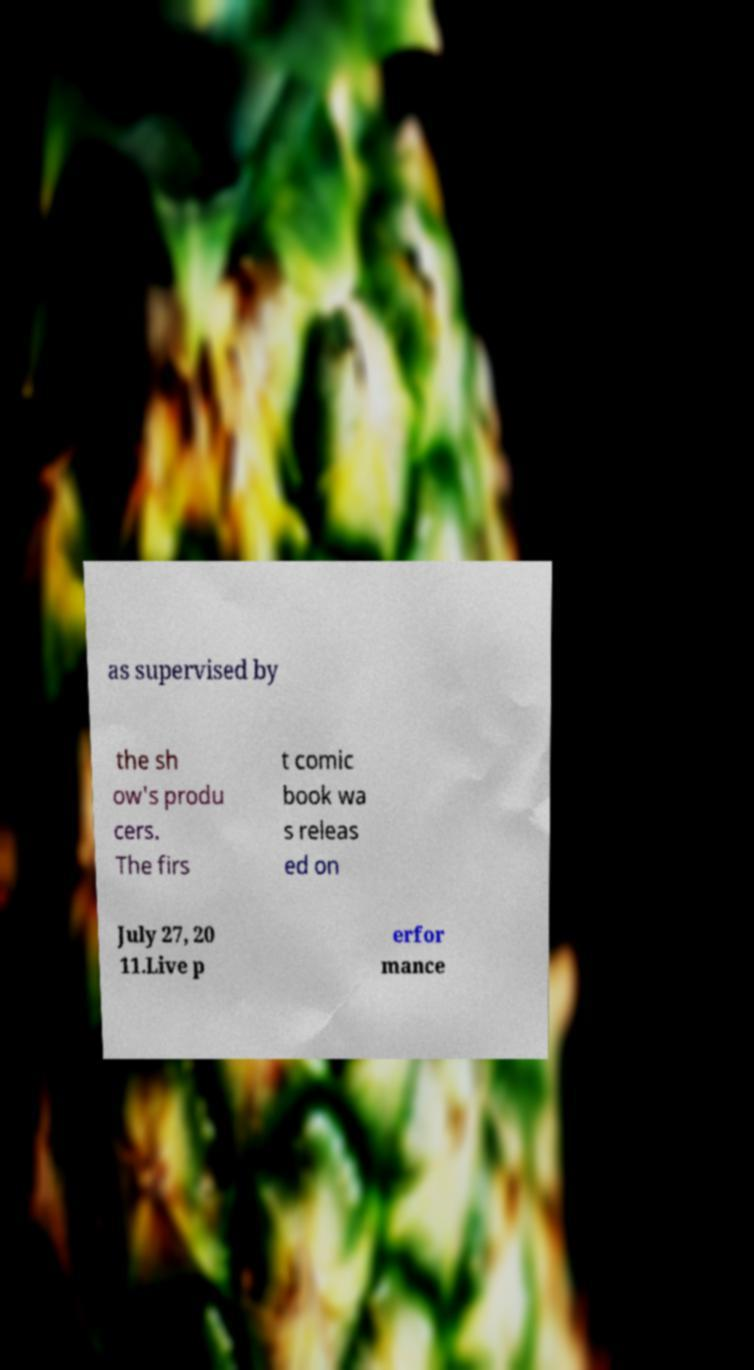Can you read and provide the text displayed in the image?This photo seems to have some interesting text. Can you extract and type it out for me? as supervised by the sh ow's produ cers. The firs t comic book wa s releas ed on July 27, 20 11.Live p erfor mance 